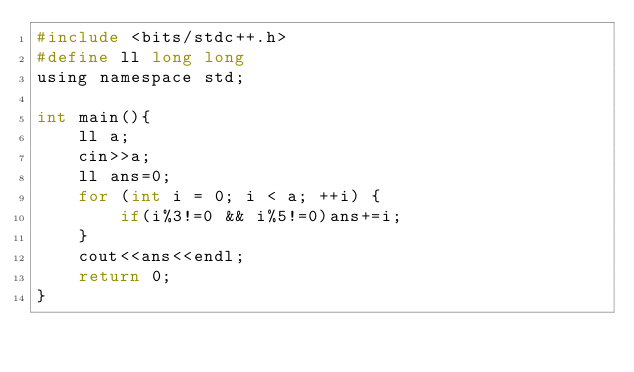Convert code to text. <code><loc_0><loc_0><loc_500><loc_500><_C_>#include <bits/stdc++.h>
#define ll long long
using namespace std;

int main(){
    ll a;
    cin>>a;
    ll ans=0;
    for (int i = 0; i < a; ++i) {
        if(i%3!=0 && i%5!=0)ans+=i;
    }
    cout<<ans<<endl;
    return 0;
}
</code> 